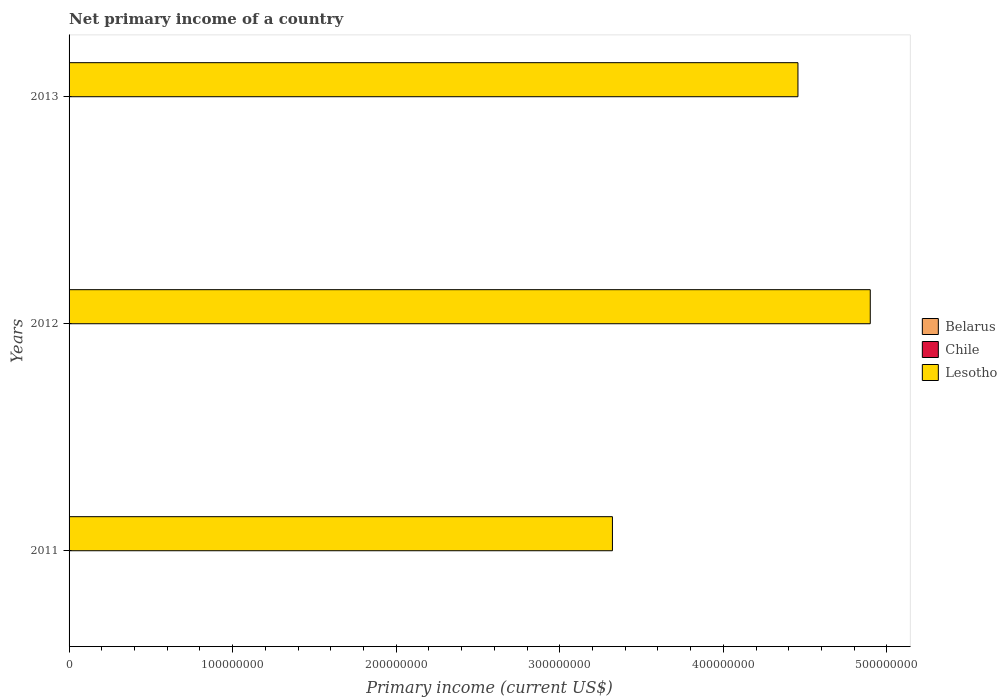How many different coloured bars are there?
Your answer should be very brief. 1. Are the number of bars on each tick of the Y-axis equal?
Your answer should be compact. Yes. How many bars are there on the 2nd tick from the bottom?
Offer a very short reply. 1. In how many cases, is the number of bars for a given year not equal to the number of legend labels?
Keep it short and to the point. 3. What is the primary income in Belarus in 2011?
Give a very brief answer. 0. Across all years, what is the maximum primary income in Lesotho?
Give a very brief answer. 4.90e+08. What is the total primary income in Lesotho in the graph?
Make the answer very short. 1.27e+09. What is the difference between the primary income in Lesotho in 2011 and that in 2013?
Your response must be concise. -1.13e+08. What is the difference between the primary income in Chile in 2011 and the primary income in Lesotho in 2012?
Provide a succinct answer. -4.90e+08. In how many years, is the primary income in Chile greater than 440000000 US$?
Offer a terse response. 0. What is the ratio of the primary income in Lesotho in 2012 to that in 2013?
Ensure brevity in your answer.  1.1. What is the difference between the highest and the second highest primary income in Lesotho?
Make the answer very short. 4.42e+07. What is the difference between the highest and the lowest primary income in Lesotho?
Make the answer very short. 1.58e+08. In how many years, is the primary income in Lesotho greater than the average primary income in Lesotho taken over all years?
Your answer should be very brief. 2. Is the sum of the primary income in Lesotho in 2011 and 2013 greater than the maximum primary income in Chile across all years?
Your answer should be very brief. Yes. How many years are there in the graph?
Your answer should be compact. 3. Does the graph contain any zero values?
Offer a very short reply. Yes. How are the legend labels stacked?
Keep it short and to the point. Vertical. What is the title of the graph?
Ensure brevity in your answer.  Net primary income of a country. Does "East Asia (all income levels)" appear as one of the legend labels in the graph?
Your answer should be compact. No. What is the label or title of the X-axis?
Provide a succinct answer. Primary income (current US$). What is the Primary income (current US$) of Belarus in 2011?
Ensure brevity in your answer.  0. What is the Primary income (current US$) in Lesotho in 2011?
Keep it short and to the point. 3.32e+08. What is the Primary income (current US$) of Lesotho in 2012?
Your response must be concise. 4.90e+08. What is the Primary income (current US$) in Lesotho in 2013?
Your answer should be compact. 4.46e+08. Across all years, what is the maximum Primary income (current US$) in Lesotho?
Your response must be concise. 4.90e+08. Across all years, what is the minimum Primary income (current US$) of Lesotho?
Keep it short and to the point. 3.32e+08. What is the total Primary income (current US$) of Chile in the graph?
Your answer should be very brief. 0. What is the total Primary income (current US$) of Lesotho in the graph?
Your answer should be compact. 1.27e+09. What is the difference between the Primary income (current US$) of Lesotho in 2011 and that in 2012?
Your answer should be compact. -1.58e+08. What is the difference between the Primary income (current US$) of Lesotho in 2011 and that in 2013?
Offer a terse response. -1.13e+08. What is the difference between the Primary income (current US$) in Lesotho in 2012 and that in 2013?
Offer a very short reply. 4.42e+07. What is the average Primary income (current US$) of Lesotho per year?
Keep it short and to the point. 4.23e+08. What is the ratio of the Primary income (current US$) of Lesotho in 2011 to that in 2012?
Give a very brief answer. 0.68. What is the ratio of the Primary income (current US$) in Lesotho in 2011 to that in 2013?
Offer a very short reply. 0.75. What is the ratio of the Primary income (current US$) in Lesotho in 2012 to that in 2013?
Give a very brief answer. 1.1. What is the difference between the highest and the second highest Primary income (current US$) in Lesotho?
Give a very brief answer. 4.42e+07. What is the difference between the highest and the lowest Primary income (current US$) in Lesotho?
Offer a very short reply. 1.58e+08. 